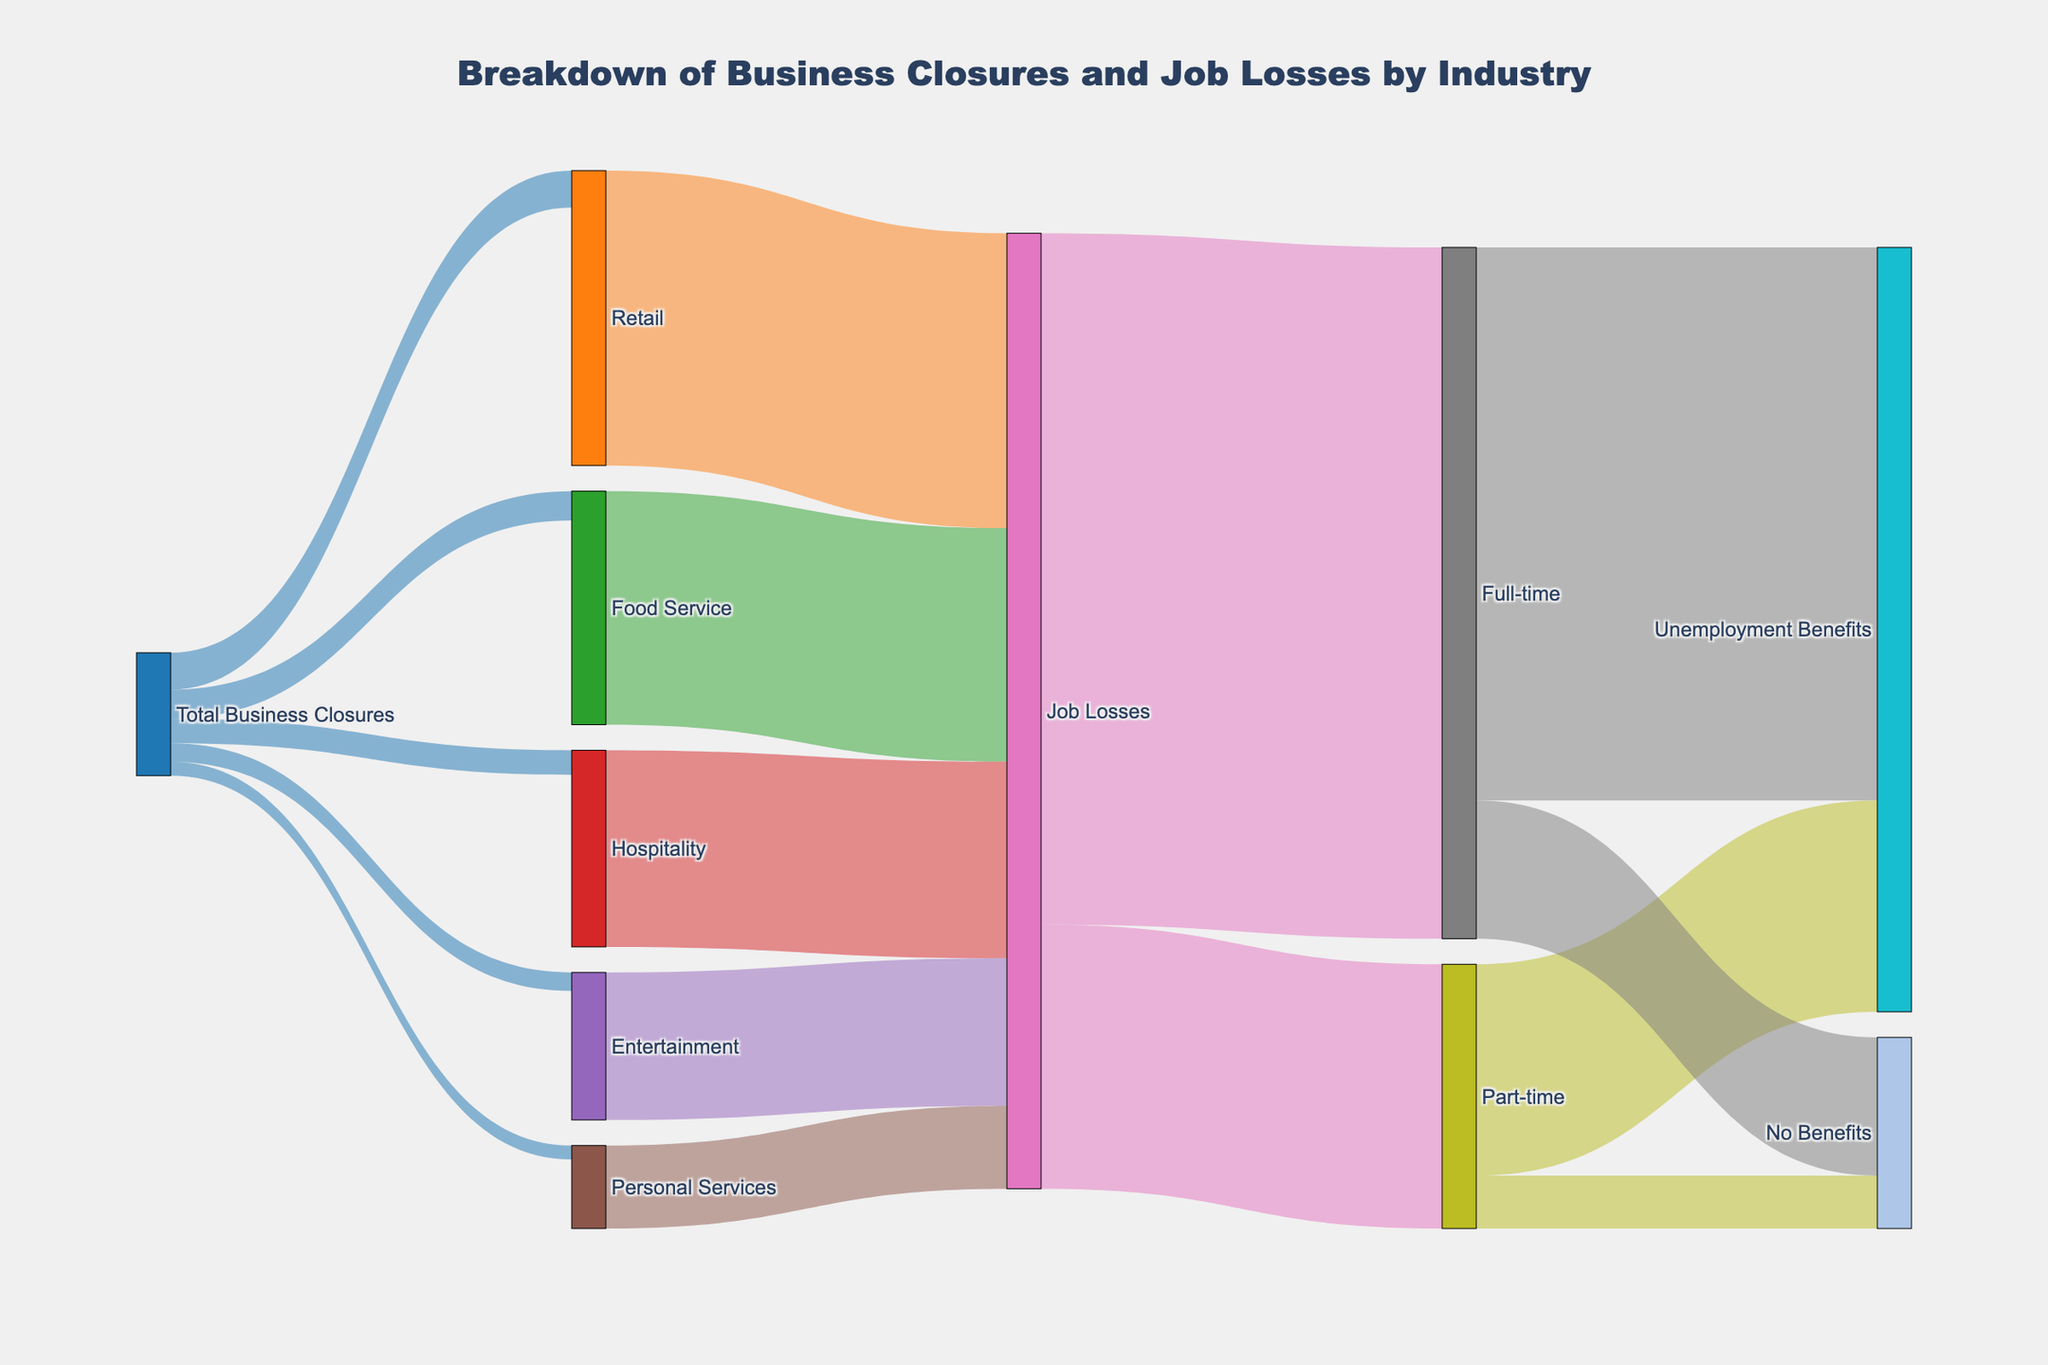What is the total number of business closures in the Retail industry? The Retail industry has a single connection from the "Total Business Closures" node, which indicates 1200 closures.
Answer: 1200 How many job losses resulted from closures in the Hospitality industry? The Hospitality industry connects to the "Job Losses" node showing a value of 6400 job losses.
Answer: 6400 How many job losses occurred in total across all industries? Sum the job losses from all industries: Retail (9600) + Food Service (7600) + Hospitality (6400) + Entertainment (4800) + Personal Services (2700) = 31,100.
Answer: 31,100 What is the difference in job losses between the Full-time and Part-time categories? Full-time job losses are 22,500, and Part-time job losses are 8600. The difference is 22,500 - 8600 = 13,900.
Answer: 13,900 Which industry experienced the second highest number of business closures? The industries and their closures are: Retail (1200), Food Service (950), Hospitality (800), Entertainment (600), and Personal Services (450). Food Service, with 950 closures, is the second highest.
Answer: Food Service What proportion of Full-time jobs lost did not receive unemployment benefits? Out of 22,500 full-time job losses, 4500 did not receive benefits. The proportion is 4500 / 22,500 = 0.2 (or 20%).
Answer: 20% How many total job losses received unemployment benefits across both Full-time and Part-time categories? For Full-time, 18,000 received benefits. For Part-time, 6880 received benefits. The total is 18,000 + 6880 = 24,880.
Answer: 24,880 Which has the greater number of job losses, the Entertainment or Personal Services industry? Entertainment has 4800 job losses, while Personal Services has 2700 job losses. Entertainment has more job losses.
Answer: Entertainment What percentage of job losses in the Food Service industry received unemployment benefits? 7600 job losses in Food Service, out of which 6880 received benefits. The percentage is (6880 / 7600) * 100 ≈ 90.53%.
Answer: 90.53% What is the total number of job losses that did not receive unemployment benefits? Full-time without benefits: 4500 Part-time without benefits: 1720. Total without benefits = 4500 + 1720 = 6220.
Answer: 6220 